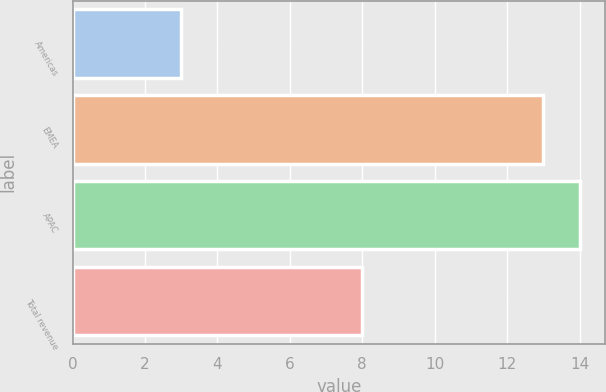<chart> <loc_0><loc_0><loc_500><loc_500><bar_chart><fcel>Americas<fcel>EMEA<fcel>APAC<fcel>Total revenue<nl><fcel>3<fcel>13<fcel>14<fcel>8<nl></chart> 